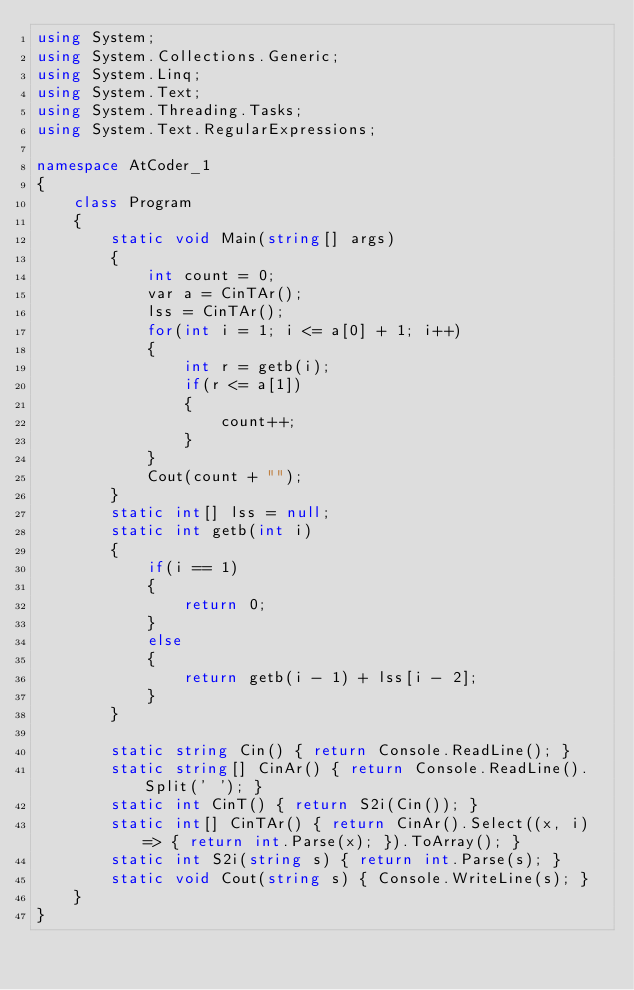<code> <loc_0><loc_0><loc_500><loc_500><_C#_>using System;
using System.Collections.Generic;
using System.Linq;
using System.Text;
using System.Threading.Tasks;
using System.Text.RegularExpressions;

namespace AtCoder_1
{
    class Program
    {
        static void Main(string[] args)
        {
            int count = 0;
            var a = CinTAr();
            lss = CinTAr();
            for(int i = 1; i <= a[0] + 1; i++)
            {
                int r = getb(i);
                if(r <= a[1])
                {
                    count++;
                }
            }
            Cout(count + "");
        }
        static int[] lss = null;
        static int getb(int i)
        {
            if(i == 1)
            {
                return 0;
            }
            else
            {
                return getb(i - 1) + lss[i - 2];
            }
        }

        static string Cin() { return Console.ReadLine(); }
        static string[] CinAr() { return Console.ReadLine().Split(' '); }
        static int CinT() { return S2i(Cin()); }
        static int[] CinTAr() { return CinAr().Select((x, i) => { return int.Parse(x); }).ToArray(); }
        static int S2i(string s) { return int.Parse(s); }
        static void Cout(string s) { Console.WriteLine(s); }
    }
}
</code> 